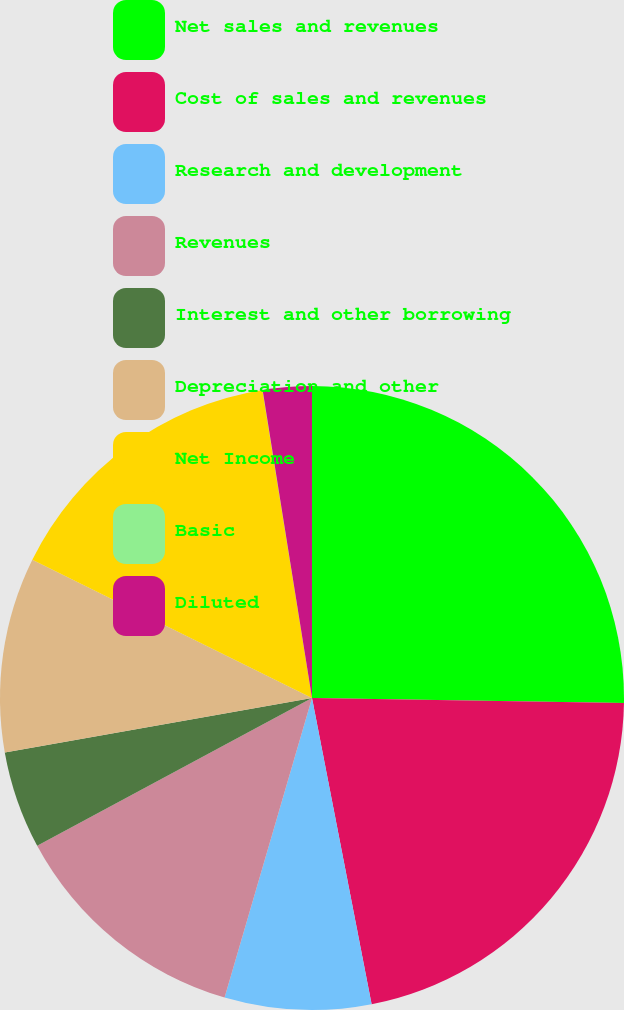Convert chart. <chart><loc_0><loc_0><loc_500><loc_500><pie_chart><fcel>Net sales and revenues<fcel>Cost of sales and revenues<fcel>Research and development<fcel>Revenues<fcel>Interest and other borrowing<fcel>Depreciation and other<fcel>Net Income<fcel>Basic<fcel>Diluted<nl><fcel>25.25%<fcel>21.69%<fcel>7.58%<fcel>12.63%<fcel>5.06%<fcel>10.1%<fcel>15.15%<fcel>0.01%<fcel>2.53%<nl></chart> 